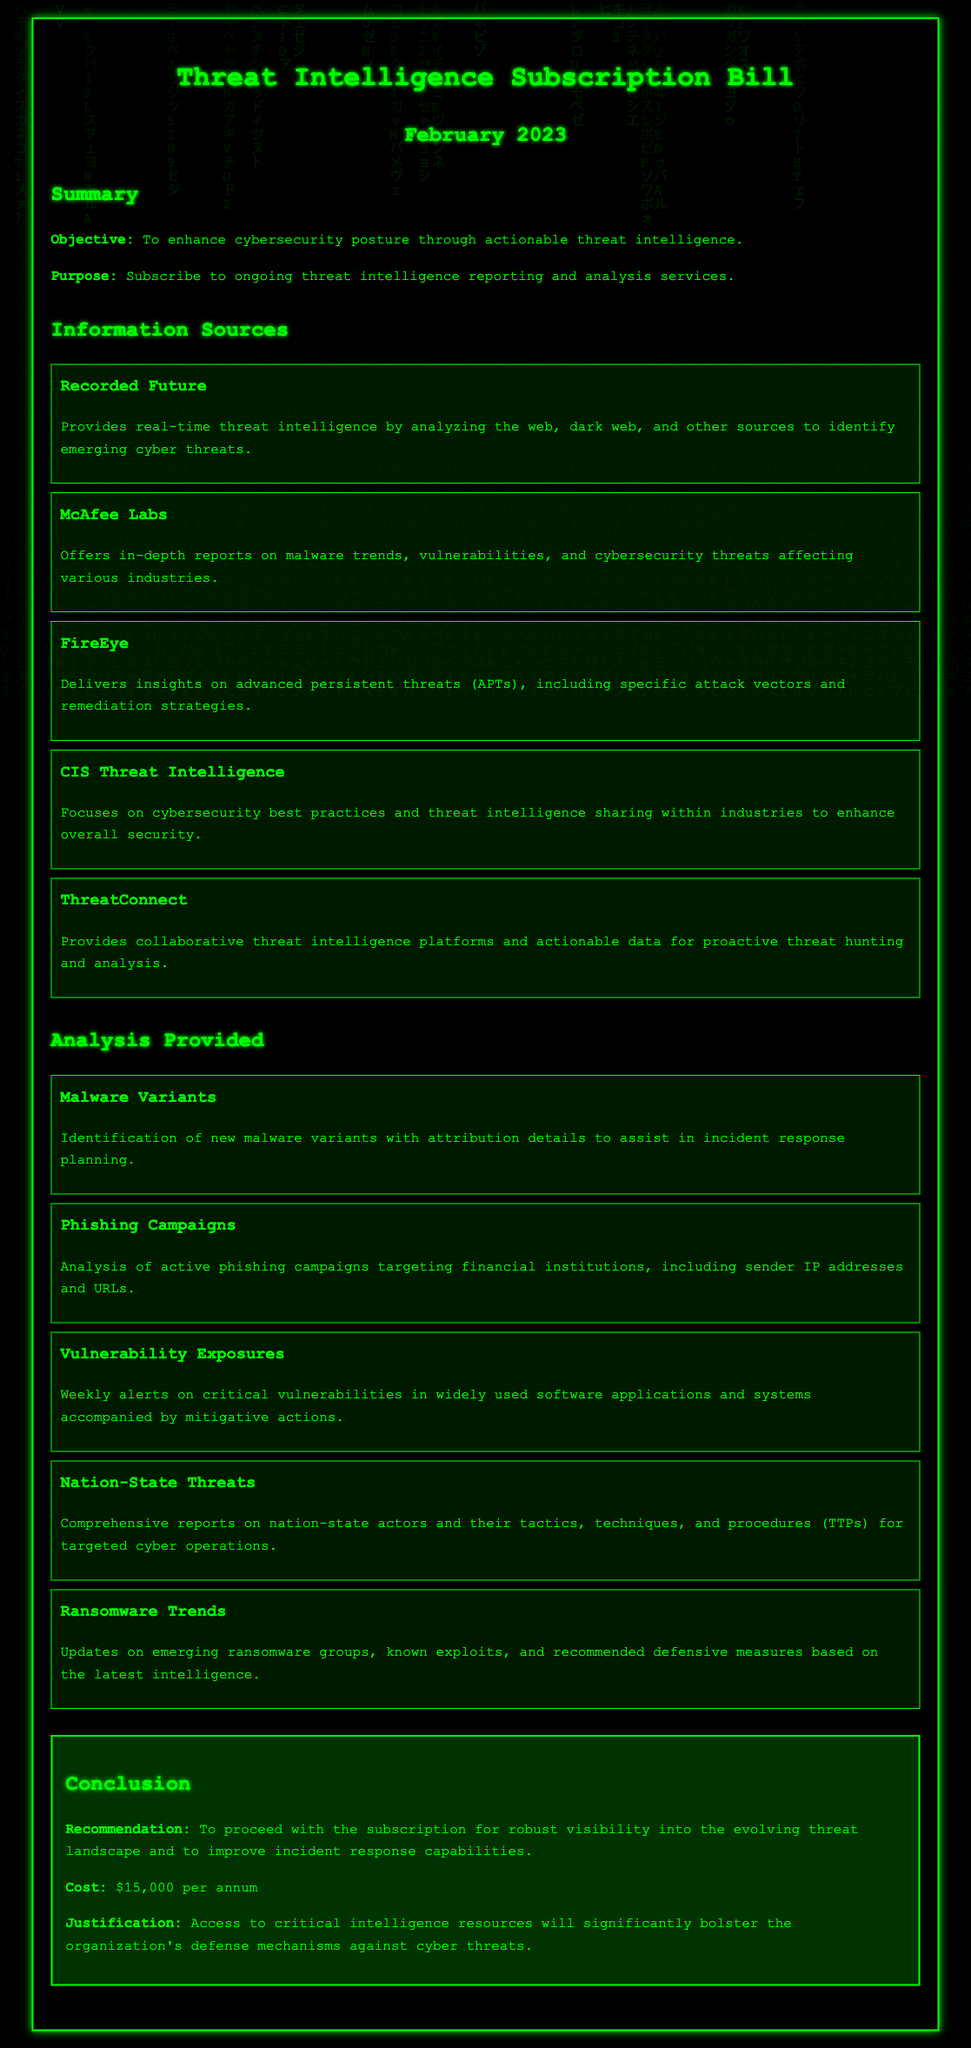What is the objective of the bill? The objective of the bill is stated as enhancing cybersecurity posture through actionable threat intelligence.
Answer: Enhance cybersecurity posture What is the cost of the subscription? The document explicitly states the cost of the subscription as $15,000 per annum.
Answer: $15,000 per annum Which organization provides real-time threat intelligence? The document mentions Recorded Future as the provider of real-time threat intelligence by analyzing various sources.
Answer: Recorded Future What type of analysis is provided regarding malware? The document outlines identification of new malware variants with attribution details for incident response planning as part of the analysis.
Answer: Identification of new malware variants What is noted about phishing campaigns? The analysis section mentions an analysis of active phishing campaigns targeting financial institutions, including specific IP addresses and URLs.
Answer: Analysis of active phishing campaigns What is the recommendation given in the conclusion? The recommendation provided in the conclusion is to proceed with the subscription for improved visibility into the threat landscape.
Answer: Proceed with the subscription What does CIS Threat Intelligence focus on? The document specifies that CIS Threat Intelligence focuses on cybersecurity best practices and threat intelligence sharing.
Answer: Cybersecurity best practices What type of threats are reported regarding nation-state actors? The analysis section provides comprehensive reports on nation-state actors, including their tactics, techniques, and procedures.
Answer: Comprehensive reports on nation-state actors 